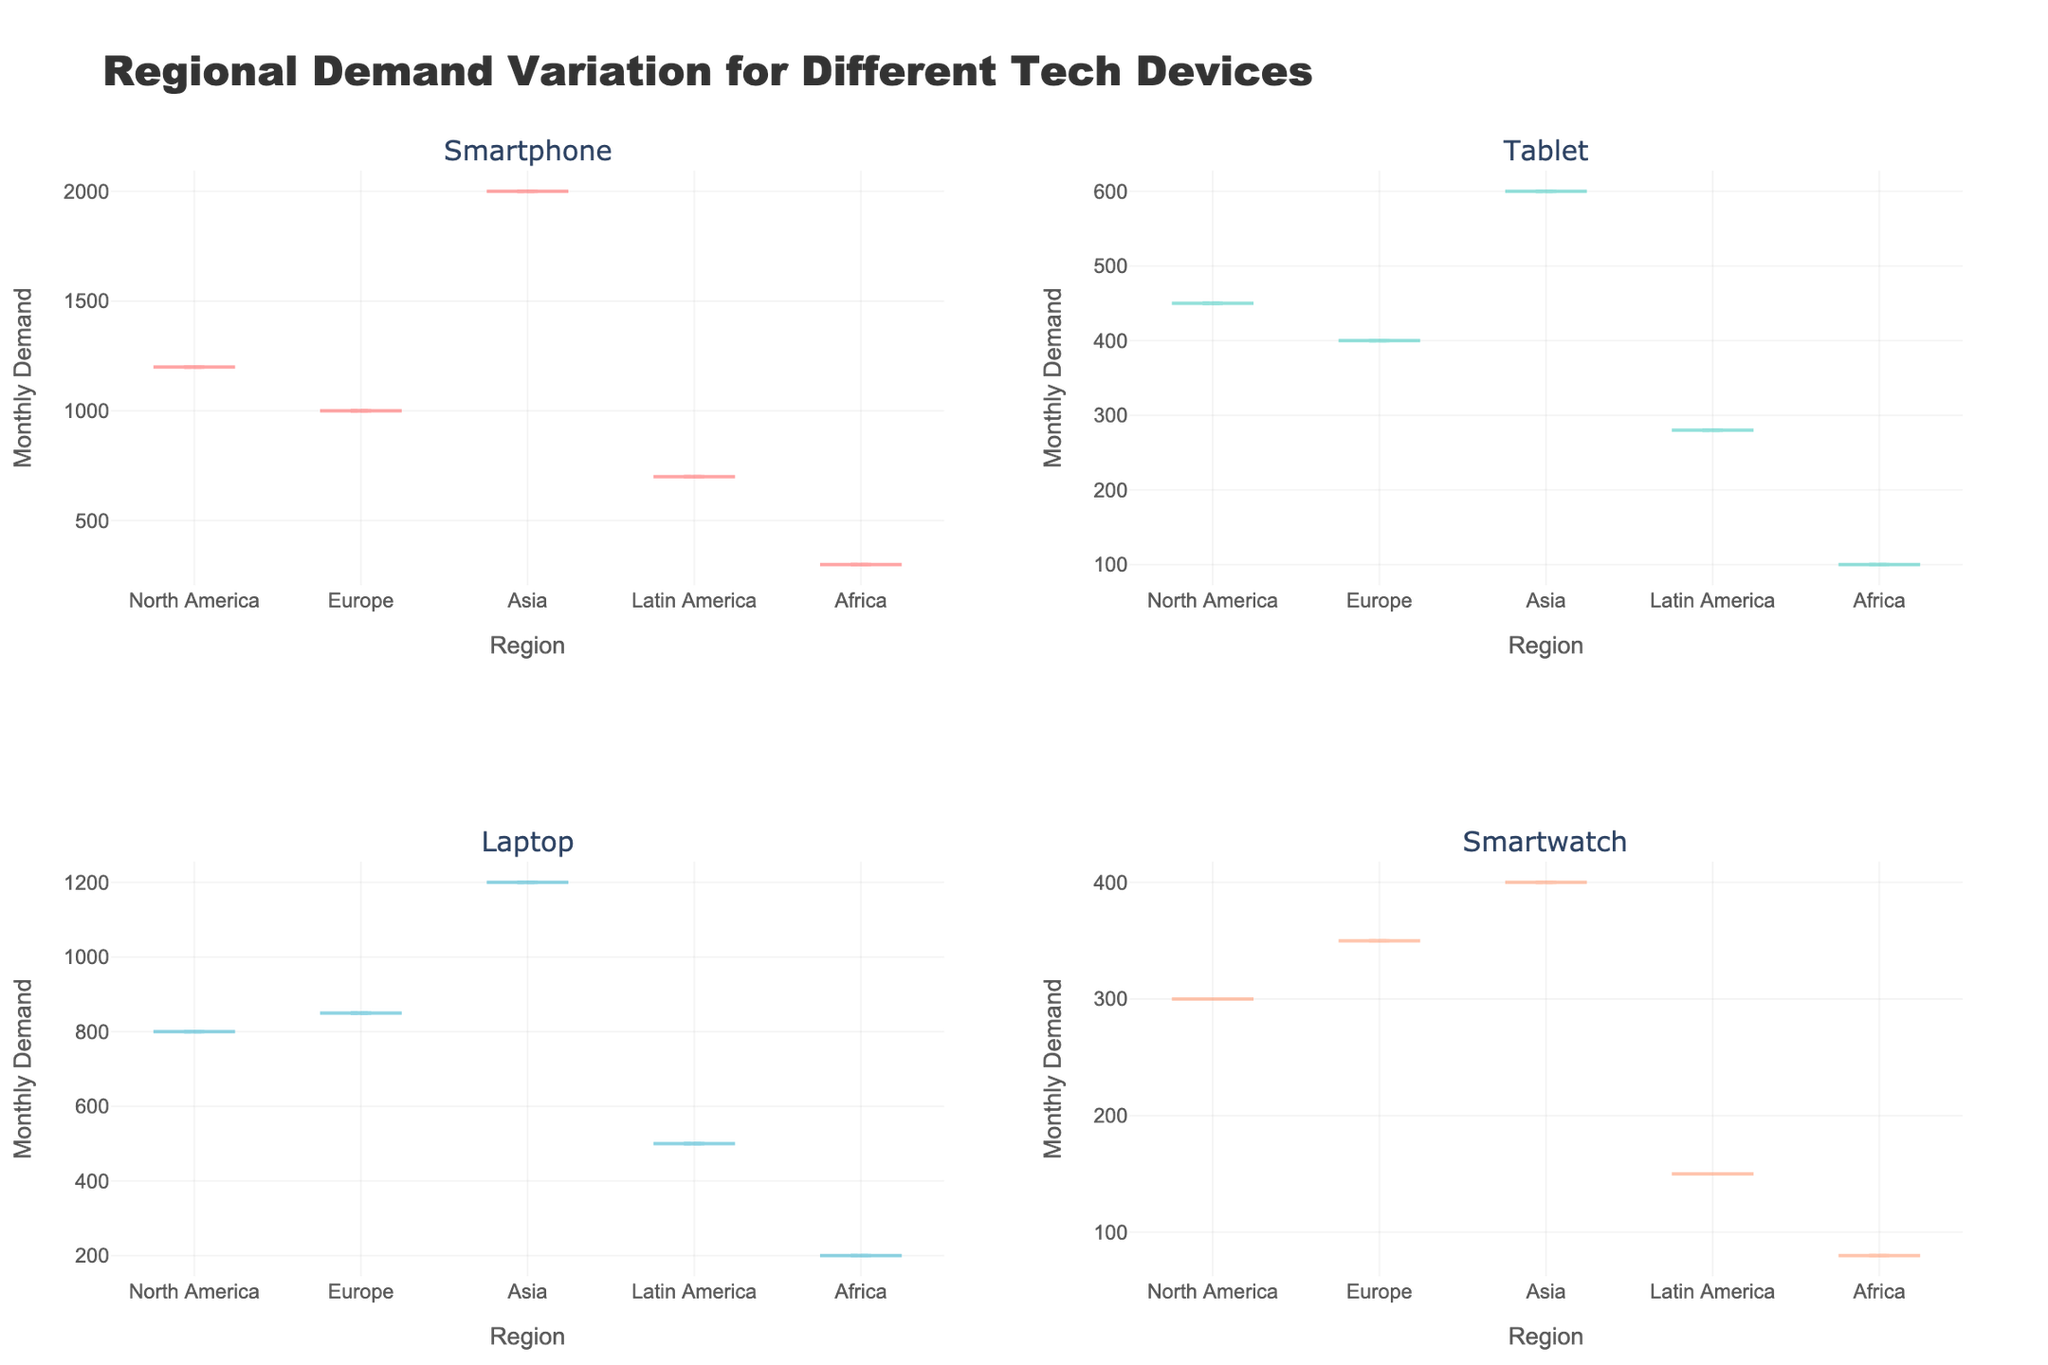How many regions are displayed in each subplot? There are four subplots corresponding to Smartphones, Tablets, Laptops, and Smartwatches. Each subplot has data for five regions: North America, Europe, Asia, Latin America, and Africa.
Answer: 5 Which device has the highest monthly demand in Asia? In the Asia subplot, the Smartphone category shows a significantly higher monthly demand compared to other devices, reaching up to 2000.
Answer: Smartphone What is the title of the figure? The title of the figure is displayed at the top and reads "Regional Demand Variation for Different Tech Devices".
Answer: Regional Demand Variation for Different Tech Devices Compare the monthly demand for Smartwatches between North America and Africa. Which region has a higher demand? By observing the Smartwatch subplot, North America has a higher monthly demand (around 300) compared to Africa (around 80).
Answer: North America What is the average monthly demand for tablets across all regions? To find the average, sum the monthly demand for Tablets across all regions: (450 + 400 + 600 + 280 + 100) = 1830. Then, divide by the number of regions (5). 1830 / 5 = 366.
Answer: 366 Which region has the lowest monthly demand for laptops? Observing the Laptop subplot, Africa shows the lowest monthly demand with around 200 units.
Answer: Africa How does the monthly demand for smartphones in Europe compare to that in North America? In the Smartphone subplot, the monthly demand in North America is around 1200, whereas Europe shows a demand of about 1000, indicating North America has a higher demand.
Answer: North America Is the variance in monthly demand for tablets higher in Asia or in Latin America? The visualization of variance in the Tablet subplot shows that the spread (variance) of demand values is wider in Asia compared to Latin America, indicating higher variance in Asia.
Answer: Asia Which device has the lowest monthly demand in Latin America? By looking at the Latin America data across each subplot, the Smartwatch shows the lowest monthly demand, around 150 units.
Answer: Smartwatch 